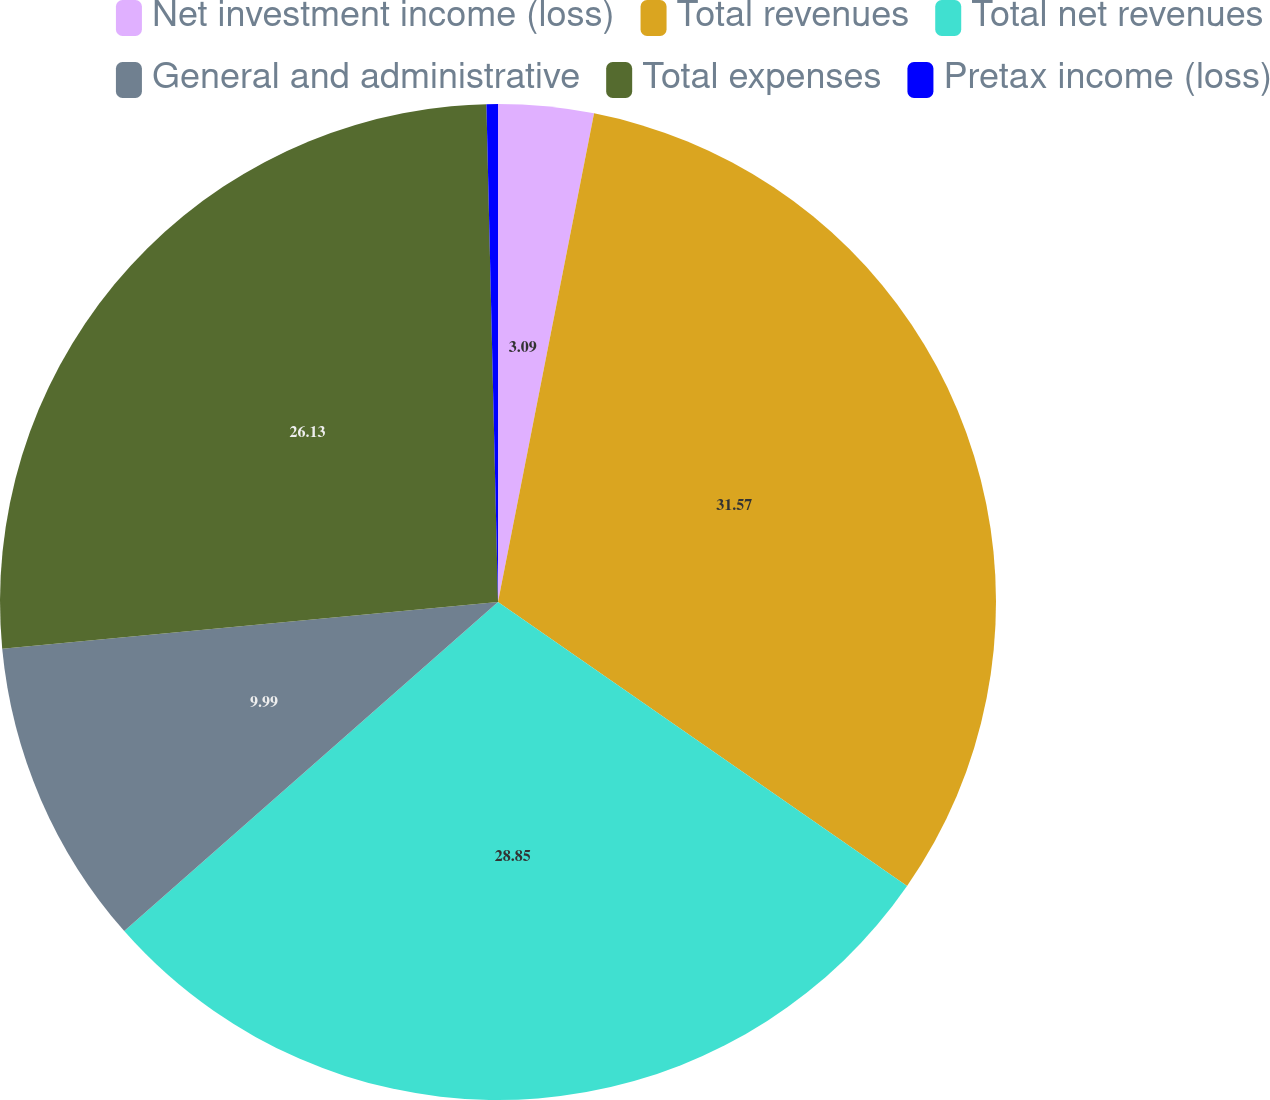Convert chart to OTSL. <chart><loc_0><loc_0><loc_500><loc_500><pie_chart><fcel>Net investment income (loss)<fcel>Total revenues<fcel>Total net revenues<fcel>General and administrative<fcel>Total expenses<fcel>Pretax income (loss)<nl><fcel>3.09%<fcel>31.57%<fcel>28.85%<fcel>9.99%<fcel>26.13%<fcel>0.37%<nl></chart> 